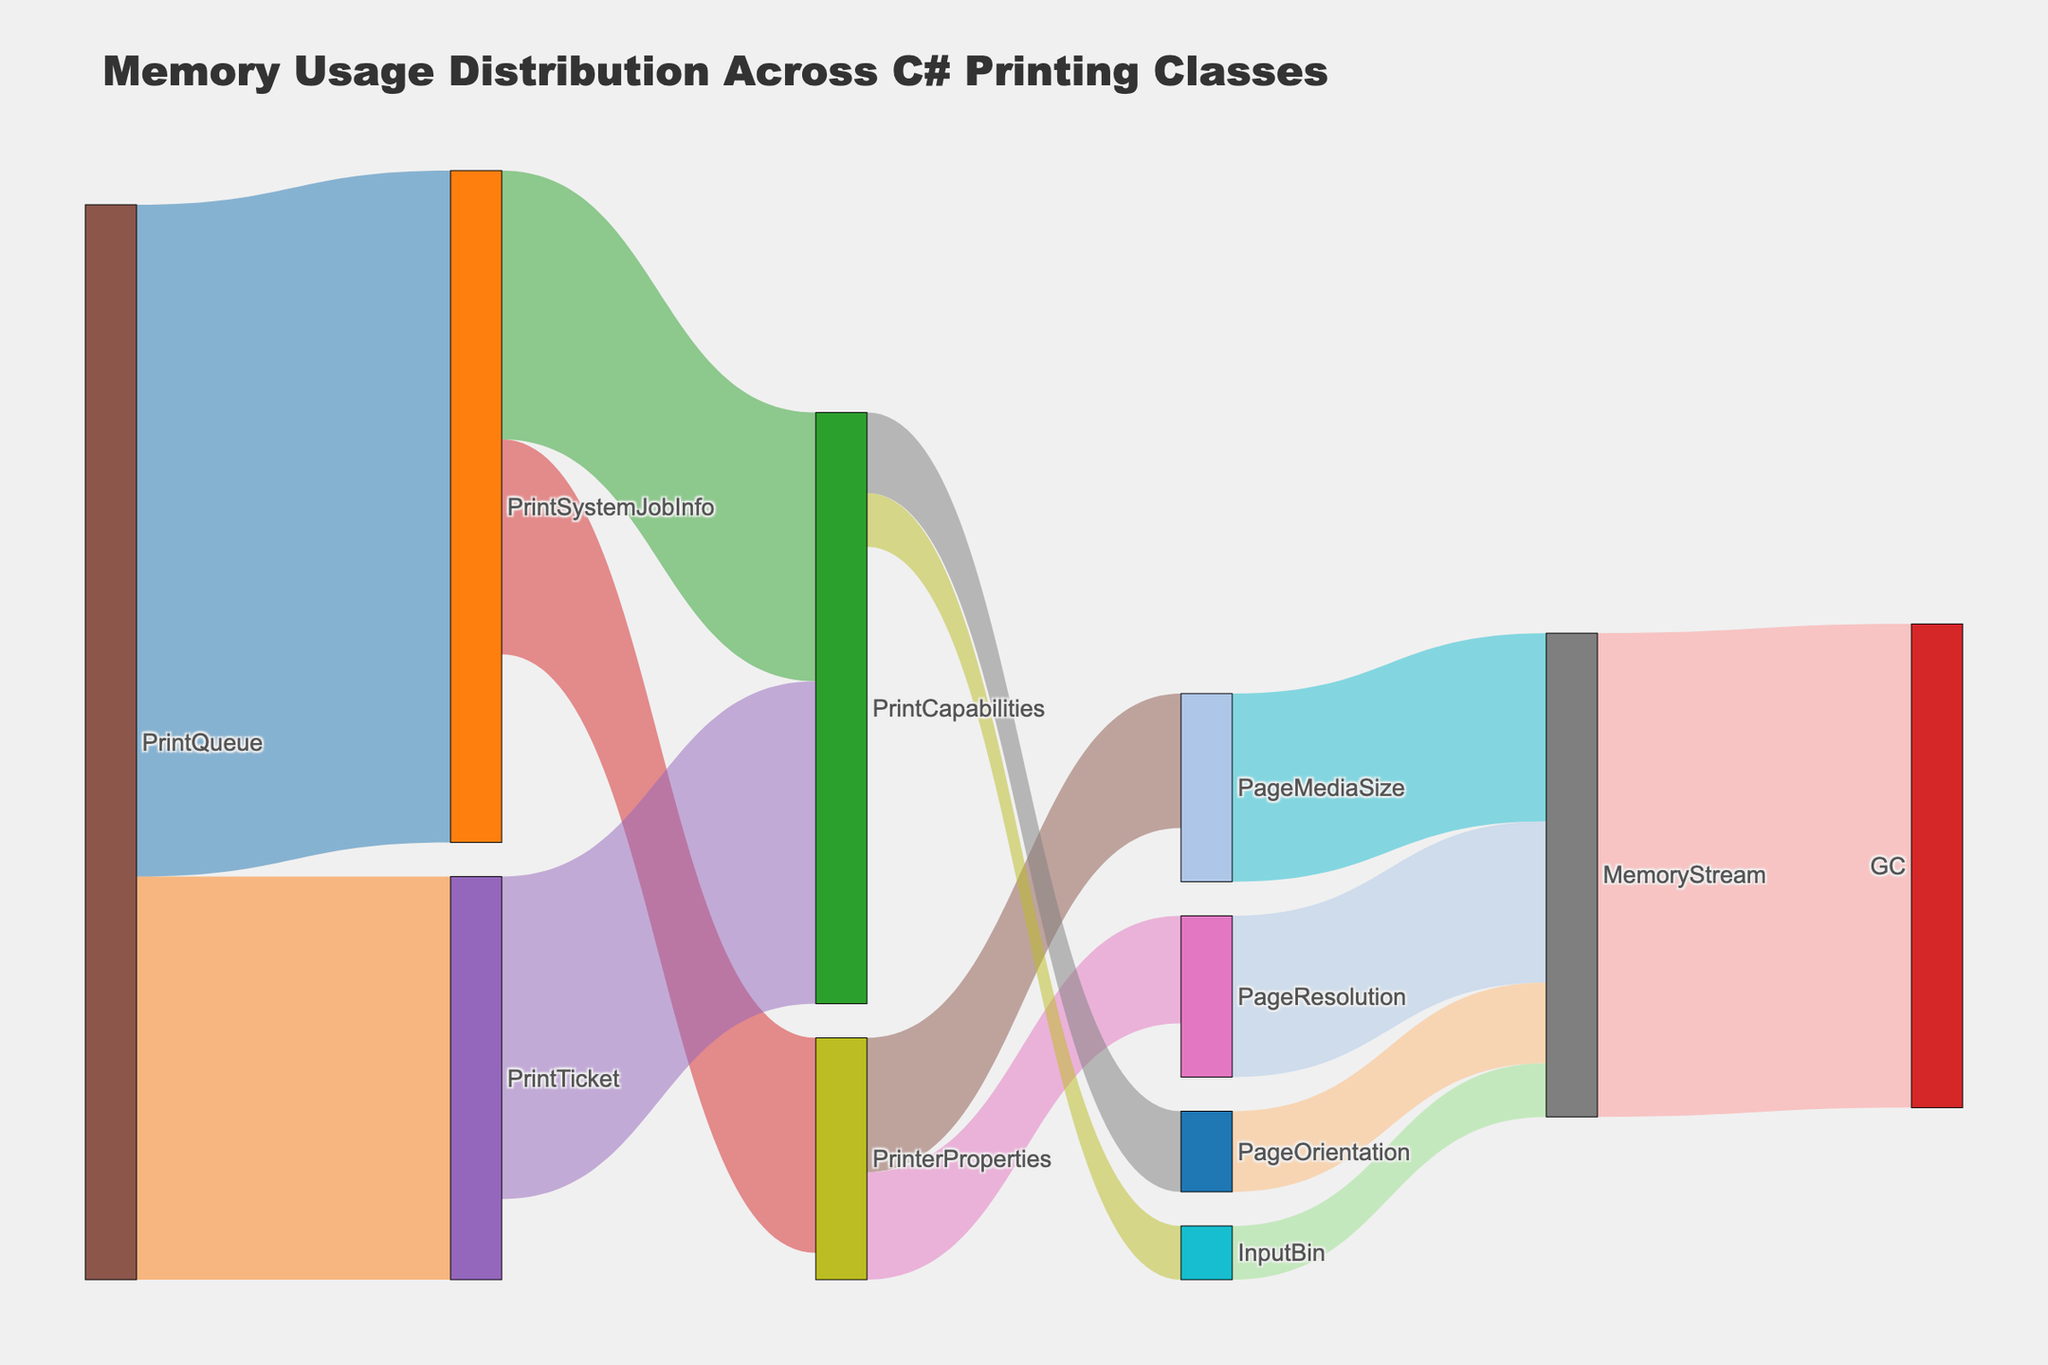What is the title of the figure? The title is located at the top of the figure and provides a summary of what the figure represents. Here, the title is "Memory Usage Distribution Across C# Printing Classes".
Answer: Memory Usage Distribution Across C# Printing Classes Which class uses the most memory directly? The class with the largest value in the figure is the one that uses the most memory directly. Here, "PrintQueue" has the largest memory usage of 25 MB.
Answer: PrintQueue How much memory is used by the "PrintTicket" class? Refer to the figure and look at the value associated with the "PrintTicket" class. It shows 15 MB.
Answer: 15 MB What is the total memory used by the "PrinterProperties" class and its components? To answer this, sum the memory values that flow from "PrinterProperties" to other classes: 5 MB (PageMediaSize) + 4 MB (PageResolution) = 9 MB. Add any memory flow directly involving "PrinterProperties" if applicable.
Answer: 9 MB Which class has the least memory usage? Identify the class with the smallest value. Here, "InputBin" uses 2 MB which is the smallest value.
Answer: InputBin How does the "MemoryStream" class fit into the memory distribution? Look at where "MemoryStream" appears in the figure. It aggregates memory from several classes: 7 MB from PageMediaSize, 6 MB from PageResolution, 3 MB from PageOrientation, and 2 MB from InputBin. Total: 7 + 6 + 3 + 2 = 18 MB flowing into "MemoryStream", and then same 18 MB flowing out to "GC".
Answer: It aggregates 18 MB then passes it to GC What is the combined memory usage of "PrintSystemJobInfo" and its subcomponents? Add the memory values directly used by "PrintSystemJobInfo" and its subcomponents: 10 (PrintCapabilities) + 8 (PrinterProperties) + Memory used by components within PrinterProperties (9) = 10 + 8 + 9 = 27 MB.
Answer: 27 MB Which paths lead to the "GC" node and what are their total values? Identify the flows leading to "GC". Here, only the "MemoryStream" flows into "GC" with a value of 18 MB. So, the total is 18 MB.
Answer: MemoryStream; 18 MB Compare the memory usage between "PrintQueue" and "PrintSystemJobInfo". Which class uses more memory by itself? Examine the values associated with "PrintQueue" and "PrintSystemJobInfo". PrintQueue uses 25 MB, and PrintSystemJobInfo uses (10 + 8) = 18 MB. So, "PrintQueue" uses more memory by itself.
Answer: PrintQueue Describe the memory distribution of the "PrintQueue" class. Identify the immediate targets from "PrintQueue" and sum values. PrintQueue splits into 25 MB (PrintSystemJobInfo) and 15 MB (PrintTicket).
Answer: 25 MB to PrintSystemJobInfo, 15 MB to PrintTicket 